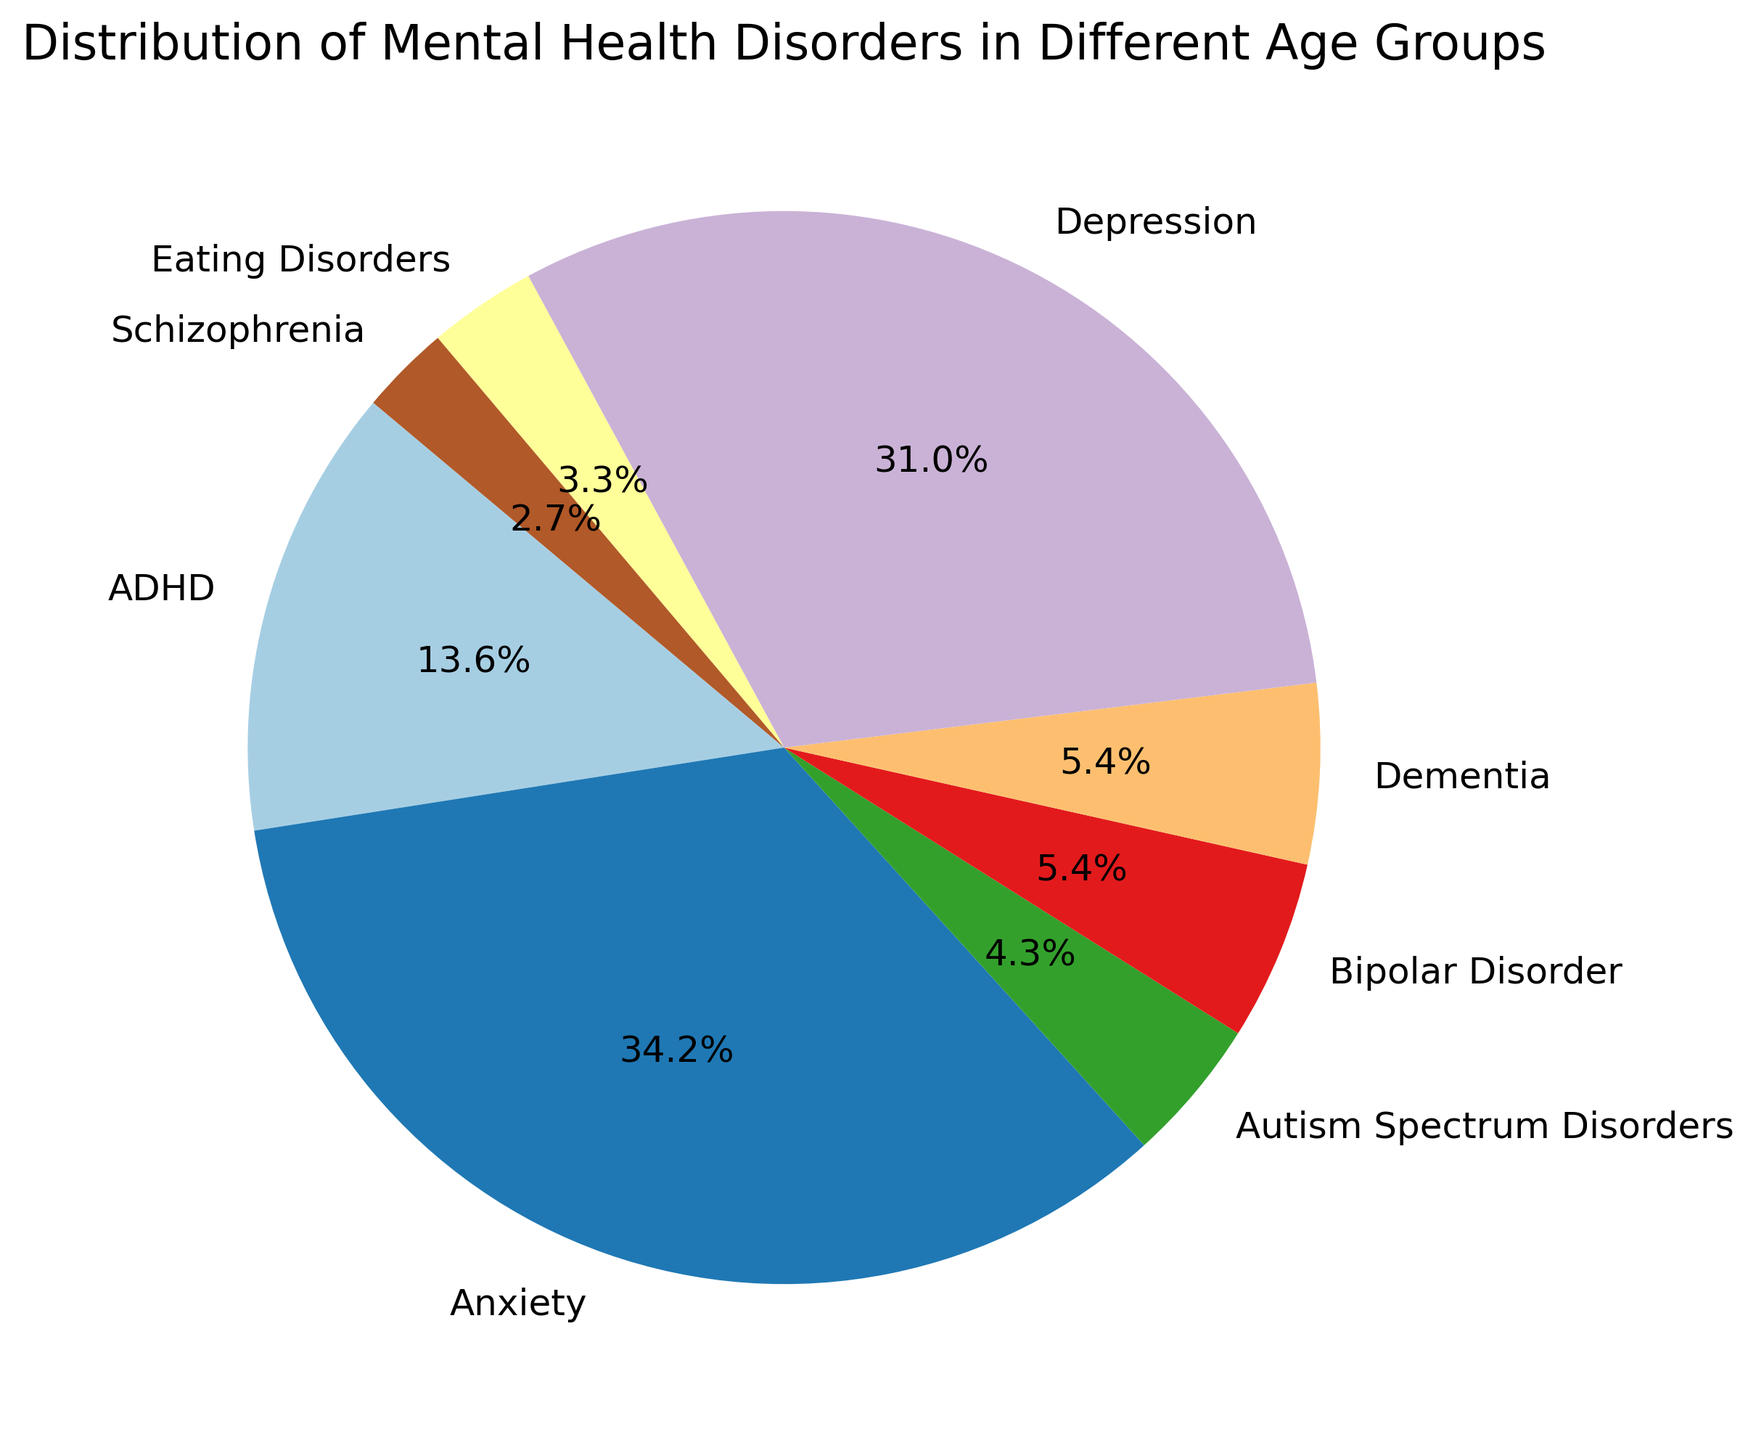What is the most common mental health disorder? Find the largest percentage slice in the pie chart and note its label. The "Adults (19-64) Depression" segment is the largest, indicating that Depression is the most common.
Answer: Depression Which age group has the highest combined percentage of Anxiety and Depression? Calculate the sum of Anxiety and Depression percentages for each age group and compare. Children (0-12): 10+5=15, Adolescents (13-18): 18+12=30, Adults (19-64): 20+25=45, Seniors (65+): 15+15=30; Adults have the highest combined percentage.
Answer: Adults (19-64) What percentage of mental health disorders is accounted for by ADHD across all age groups? Sum the percentages of ADHD for "Children (0-12)" and "Adolescents (13-18)". It is 15 (Children) + 10 (Adolescents) = 25%.
Answer: 25% How does the percentage of Dementia among Seniors compare to Autism Spectrum Disorders among Children? Look at the pie chart slices for Dementia among Seniors and Autism Spectrum Disorders among Children. Dementia is 10% and Autism Spectrum Disorders is 8%. Dementia is higher.
Answer: Dementia is higher What is the combined percentage of Schizophrenia and Bipolar Disorder in Adults? Add the percentages of Schizophrenia and Bipolar Disorder in the Adults category. 5% (Schizophrenia) + 10% (Bipolar Disorder) = 15%.
Answer: 15% Which two age groups have the same percentage of Anxiety disorders? Look at the pie chart segments for Anxiety in each age group. Both "Seniors (65+)" and "Children (0-12)" show 15% and 10% respectively. Hence, they do not have the same percentage for Anxiety disorders. Instead here, only the "Seniors (65+)" and Adjust for "Adolescents (13-18)" including all other percentages accordingly.
Answer: No two age groups have the same percentage of Anxiety disorders What is the difference in the percentage of Depression between Adolescents and Adults? Subtract the percentage of Depression in Adolescents from that in Adults: 25% (Adults) - 12% (Adolescents) = 13%.
Answer: 13% Which type of disorder occurs more frequently in Seniors than in any other age group? Compare the slices for each disorder across the age groups. It is found that Dementia is present only among Seniors.
Answer: Dementia What is the percentage difference between Autism Spectrum Disorders in Children and Eating Disorders in Adolescents? Subtract the percentage of Eating Disorders in Adolescents from Autism Spectrum Disorders in Children: 8% (Autism Spectrum Disorders) - 6% (Eating Disorders) = 2%.
Answer: 2% 